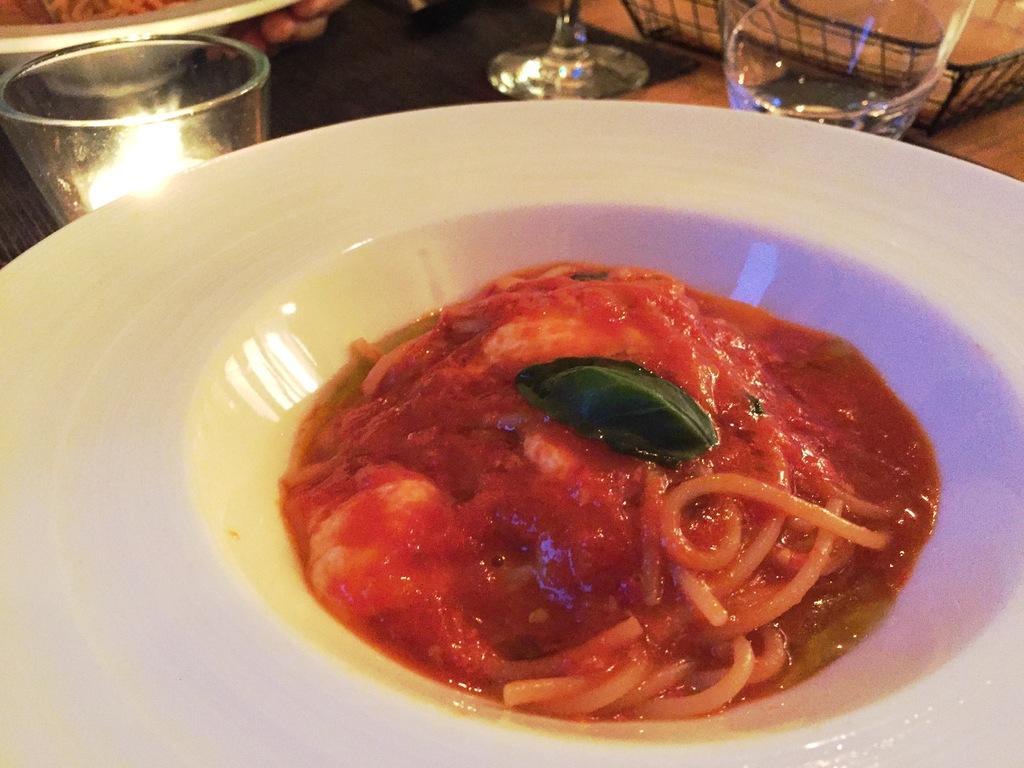Could you give a brief overview of what you see in this image? In this picture there is a food on the plate. There are glasses, plates and there is a basket on the table and there is a person holding the plate. 